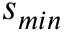Convert formula to latex. <formula><loc_0><loc_0><loc_500><loc_500>s _ { \min }</formula> 